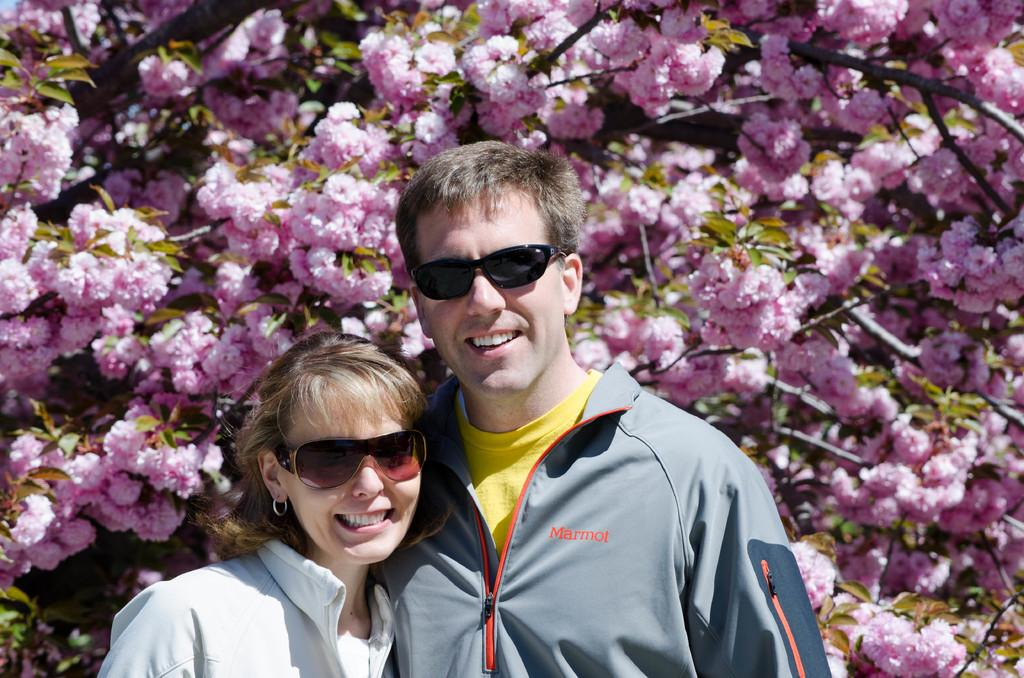Who are the people in the image? There is a lady and a man in the image. What can be seen in the background of the image? There are flowers and plants in the background of the image. What month is the lady interested in? There is no information about the month or the lady's interests in the image. 